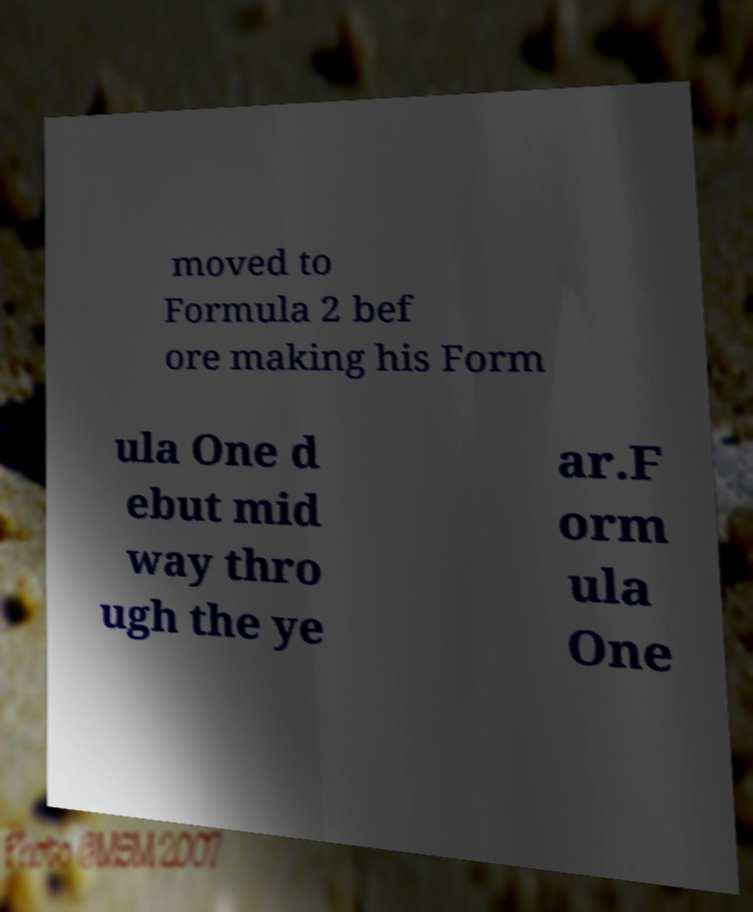There's text embedded in this image that I need extracted. Can you transcribe it verbatim? moved to Formula 2 bef ore making his Form ula One d ebut mid way thro ugh the ye ar.F orm ula One 